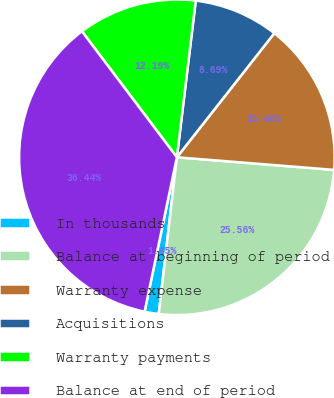Convert chart to OTSL. <chart><loc_0><loc_0><loc_500><loc_500><pie_chart><fcel>In thousands<fcel>Balance at beginning of period<fcel>Warranty expense<fcel>Acquisitions<fcel>Warranty payments<fcel>Balance at end of period<nl><fcel>1.45%<fcel>25.56%<fcel>15.68%<fcel>8.69%<fcel>12.19%<fcel>36.44%<nl></chart> 